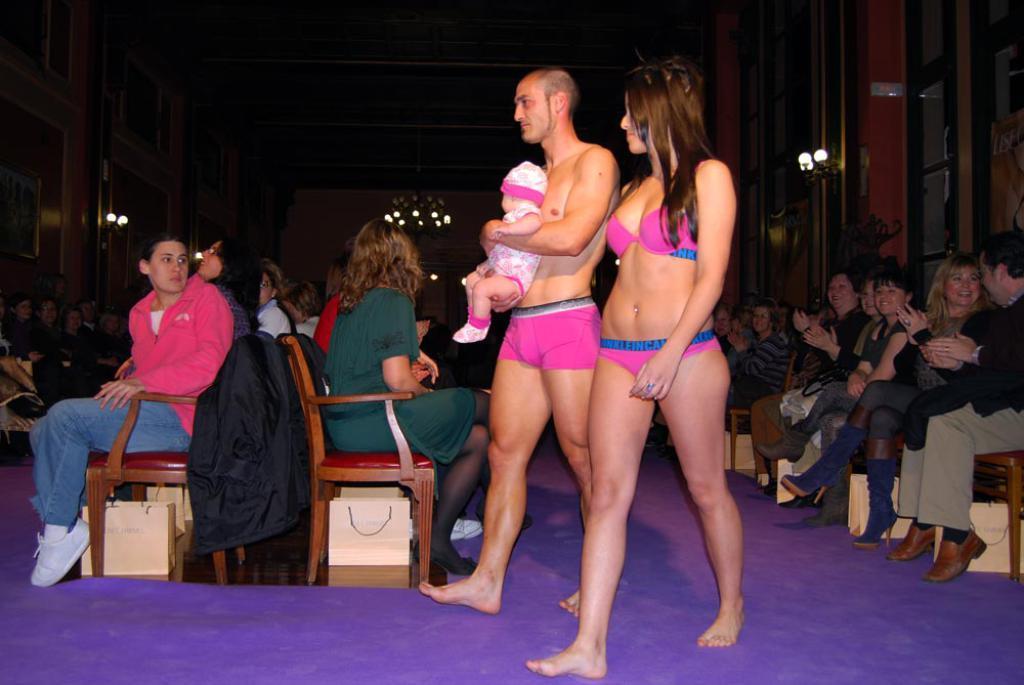Can you describe this image briefly? In this image there is a couple walking and the person holding a child, there are so many people sitting on their chairs and few are clapping with a smile on their face. In the background there are a few frames hanging on the wall and there is a chandelier. At the top of the image there is a ceiling. 